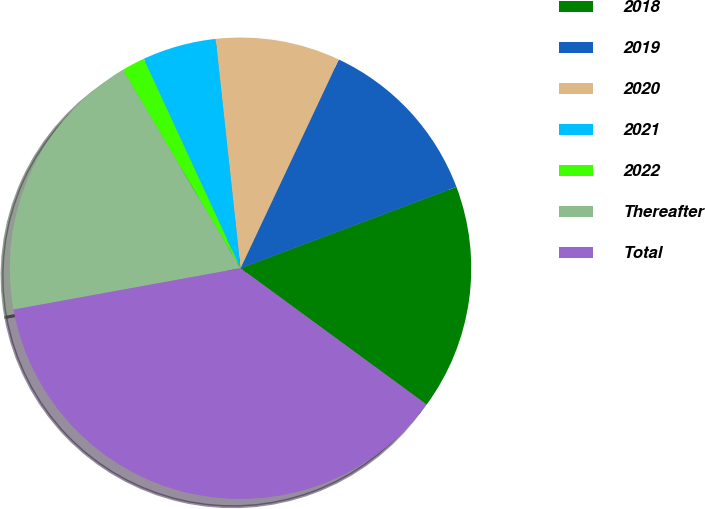<chart> <loc_0><loc_0><loc_500><loc_500><pie_chart><fcel>2018<fcel>2019<fcel>2020<fcel>2021<fcel>2022<fcel>Thereafter<fcel>Total<nl><fcel>15.8%<fcel>12.26%<fcel>8.72%<fcel>5.17%<fcel>1.63%<fcel>19.35%<fcel>37.07%<nl></chart> 